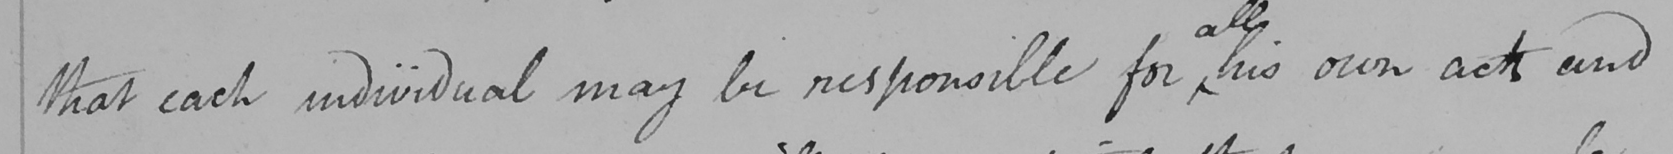Can you read and transcribe this handwriting? that each individual may be responsible for his own acts and 